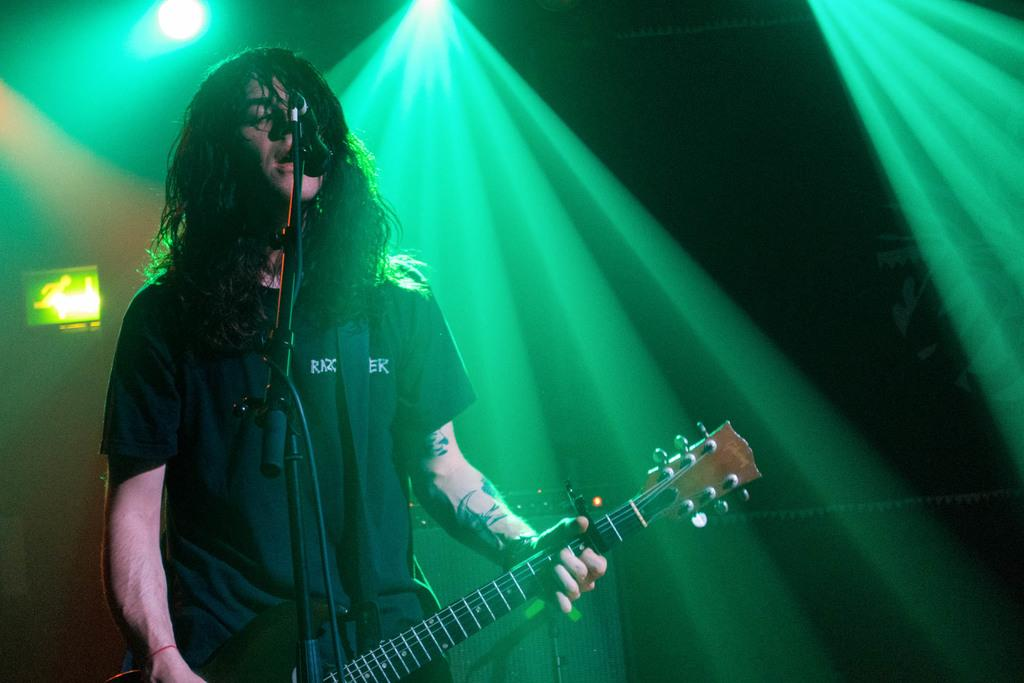What is the main subject of the image? The main subject of the image is a man. What is the man doing in the image? The man is standing in the image. What object is the man holding? The man is holding a guitar. What object is in front of the man? There is a microphone (mic) in front of the man. What type of reward is the man receiving for his performance in the image? There is no indication in the image that the man is receiving a reward for his performance. 